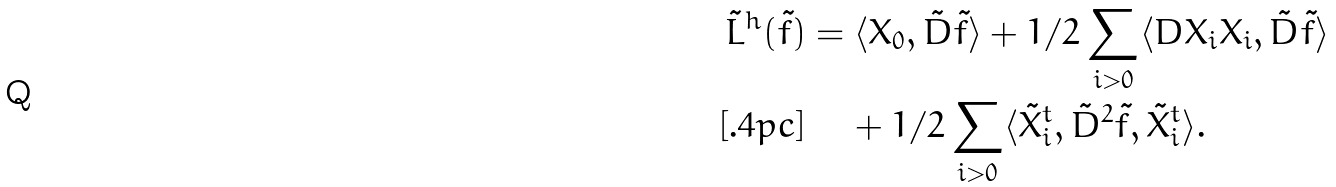<formula> <loc_0><loc_0><loc_500><loc_500>\tilde { L } ^ { h } ( \tilde { f } ) & = \langle X _ { 0 } , \tilde { D } \tilde { f } \rangle + 1 / 2 \sum _ { i > 0 } \langle D X _ { i } X _ { i } , \tilde { D } \tilde { f } \rangle \\ [ . 4 p c ] & \quad \, + 1 / 2 \sum _ { i > 0 } \langle \tilde { X } _ { i } ^ { t } , \tilde { D } ^ { 2 } \tilde { f } , \tilde { X } _ { i } ^ { t } \rangle .</formula> 